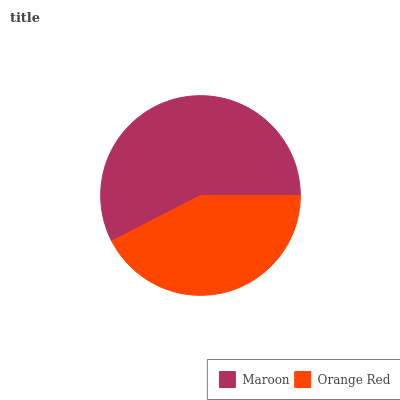Is Orange Red the minimum?
Answer yes or no. Yes. Is Maroon the maximum?
Answer yes or no. Yes. Is Orange Red the maximum?
Answer yes or no. No. Is Maroon greater than Orange Red?
Answer yes or no. Yes. Is Orange Red less than Maroon?
Answer yes or no. Yes. Is Orange Red greater than Maroon?
Answer yes or no. No. Is Maroon less than Orange Red?
Answer yes or no. No. Is Maroon the high median?
Answer yes or no. Yes. Is Orange Red the low median?
Answer yes or no. Yes. Is Orange Red the high median?
Answer yes or no. No. Is Maroon the low median?
Answer yes or no. No. 